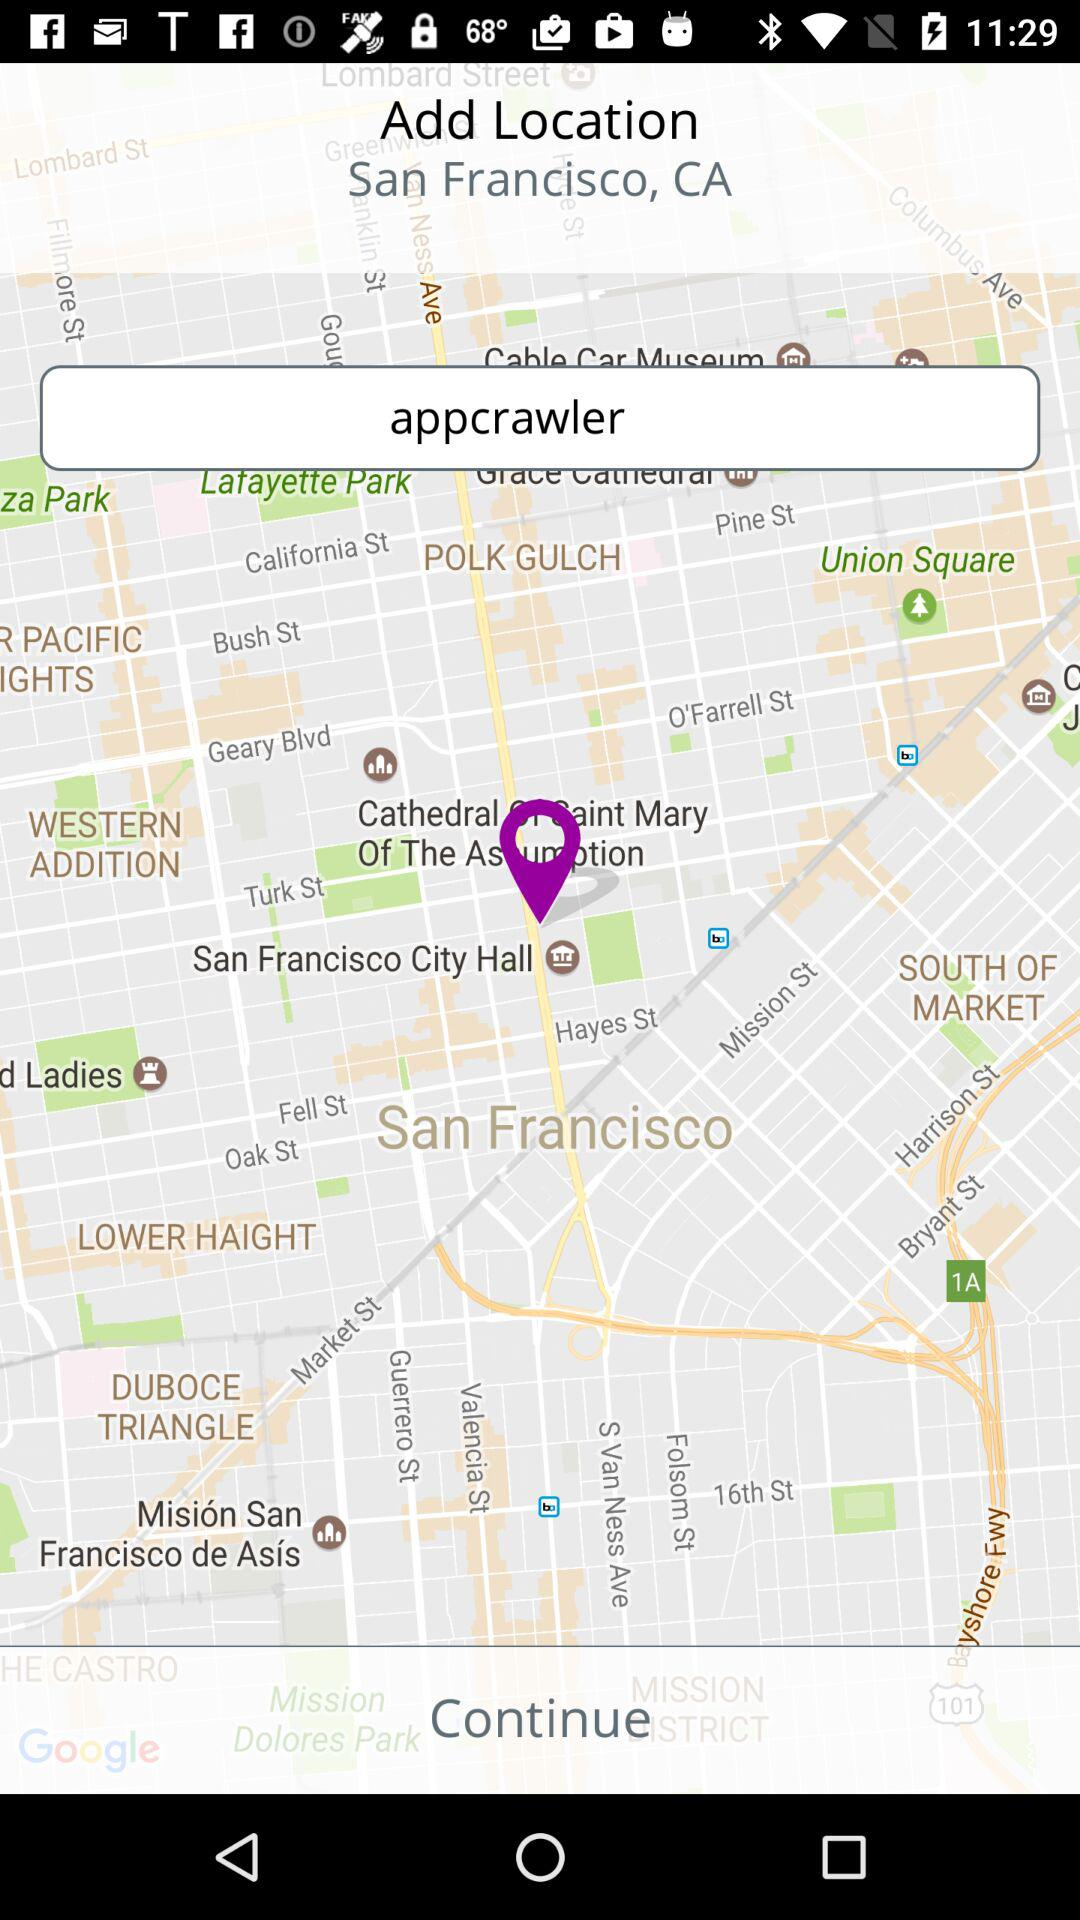What is the location? The location is San Francisco, CA. 